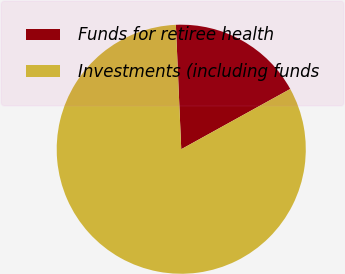<chart> <loc_0><loc_0><loc_500><loc_500><pie_chart><fcel>Funds for retiree health<fcel>Investments (including funds<nl><fcel>17.65%<fcel>82.35%<nl></chart> 